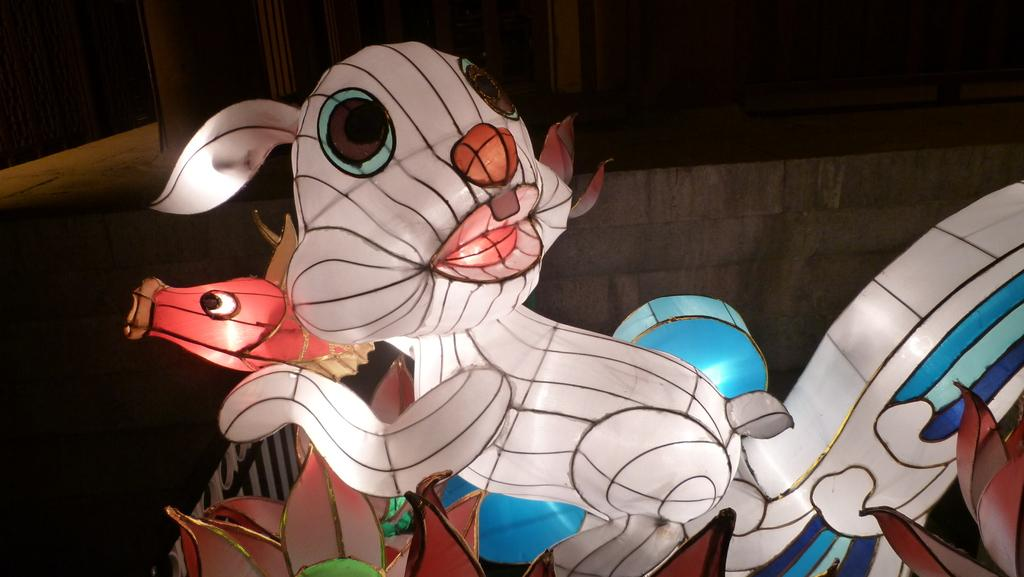What objects can be seen in the image? There are toys in the image. What can be seen in the background of the image? There is a wall and doors in the background of the image. What type of club is being used in the image? There is no club present in the image; it features toys and a background with a wall and doors. 